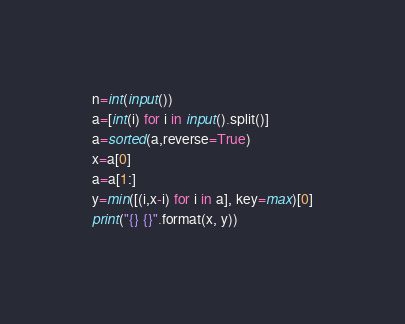Convert code to text. <code><loc_0><loc_0><loc_500><loc_500><_Python_>n=int(input())
a=[int(i) for i in input().split()]
a=sorted(a,reverse=True)
x=a[0]
a=a[1:]
y=min([(i,x-i) for i in a], key=max)[0]
print("{} {}".format(x, y))
</code> 